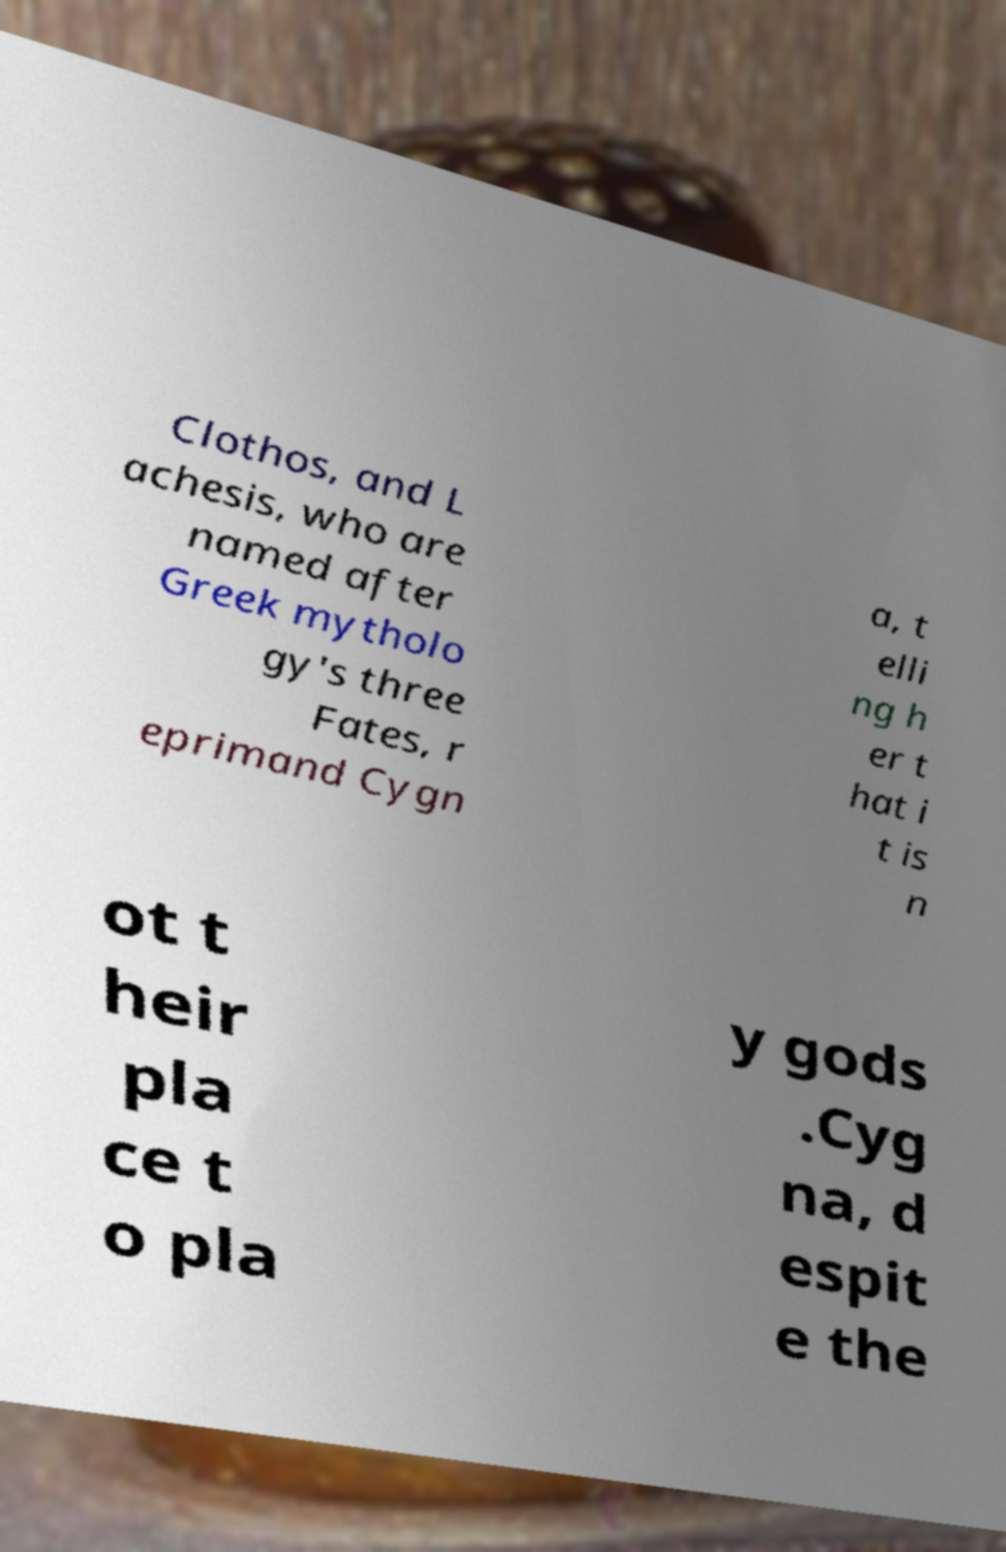Can you read and provide the text displayed in the image?This photo seems to have some interesting text. Can you extract and type it out for me? Clothos, and L achesis, who are named after Greek mytholo gy's three Fates, r eprimand Cygn a, t elli ng h er t hat i t is n ot t heir pla ce t o pla y gods .Cyg na, d espit e the 